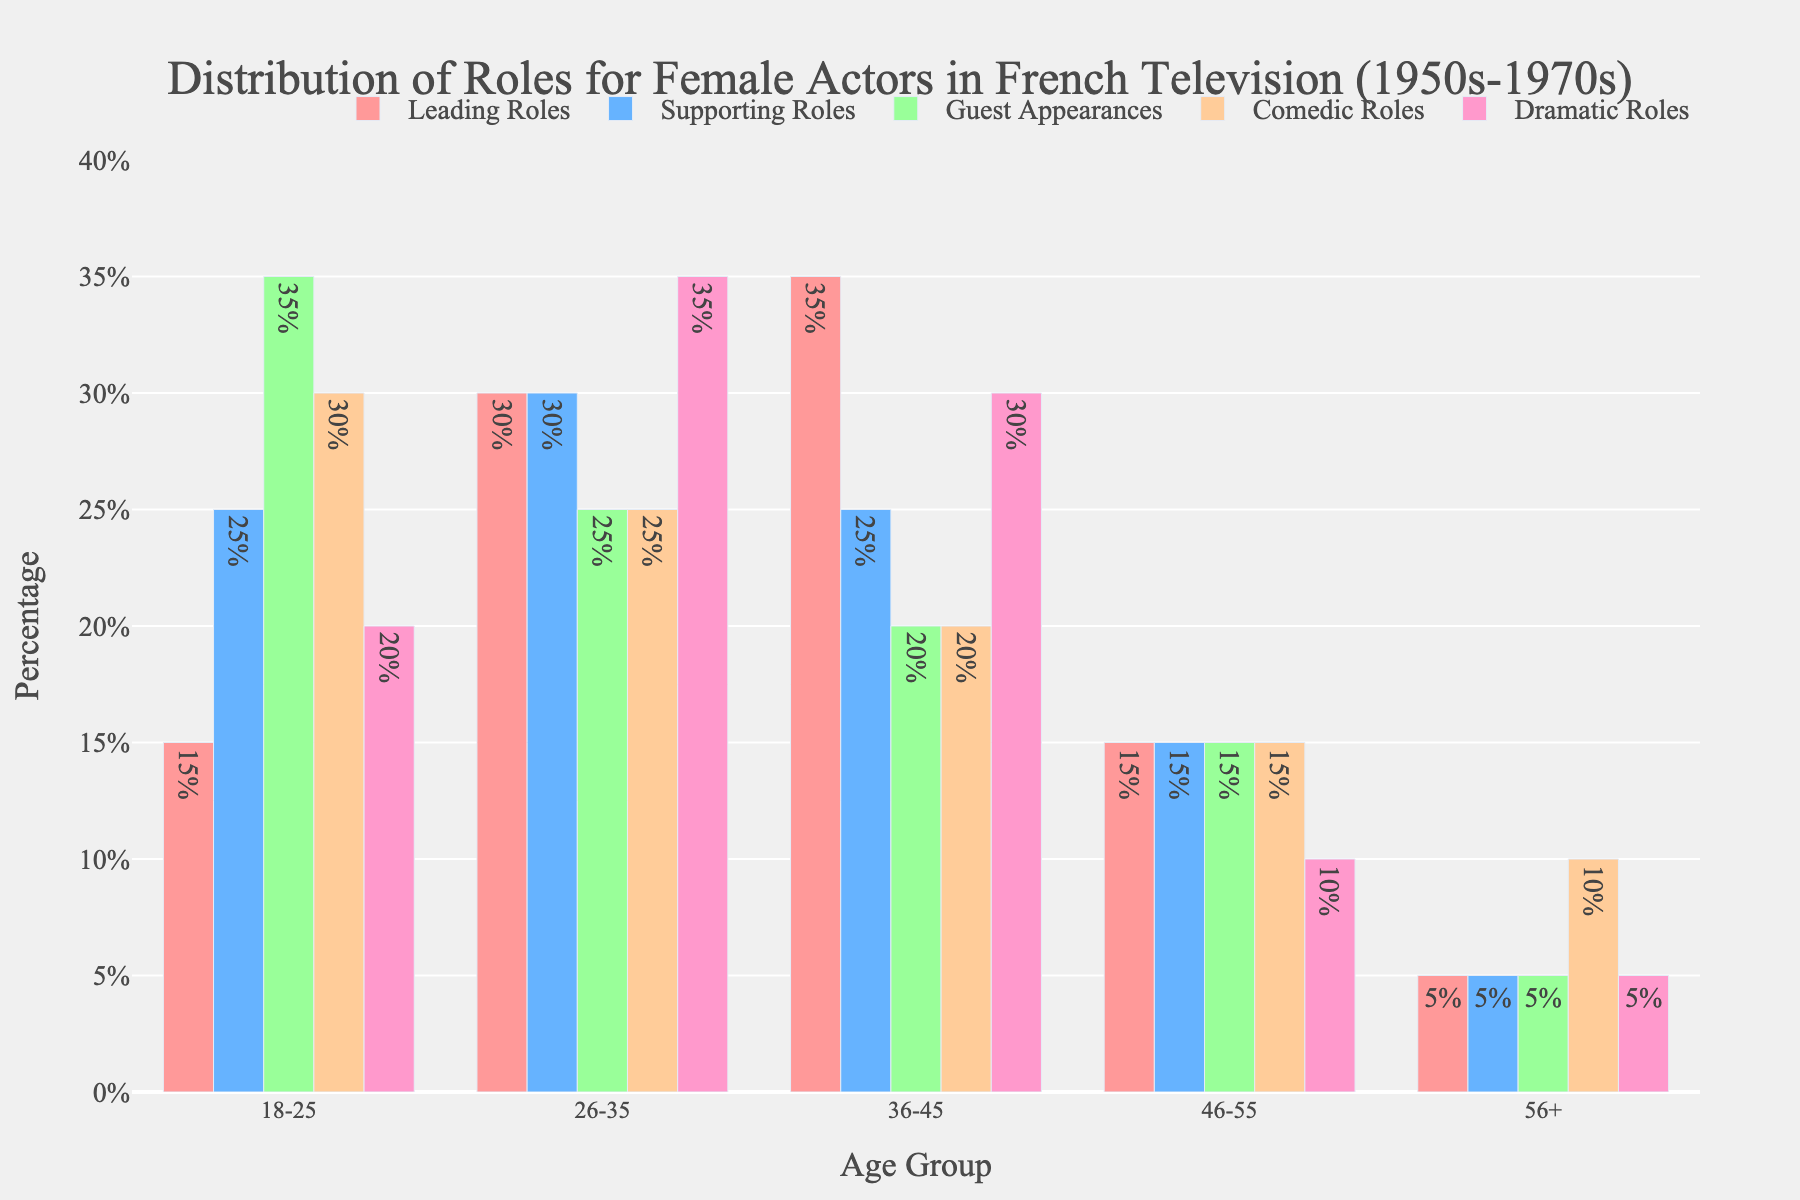Which age group has the highest percentage of leading roles? By looking at the bar representing "Leading Roles" across age groups, the tallest bar indicates the highest percentage. For Leading Roles, the tallest bar is in the age group "36-45".
Answer: 36-45 Among the age groups 26-35 and 46-55, which has a greater percentage of guest appearances? Compare the height (or length) of the bars for "Guest Appearances" in age groups 26-35 and 46-55. The bar for 26-35 is taller than 46-55.
Answer: 26-35 What is the total percentage of comedic roles for all age groups combined? Sum the percentages of "Comedic Roles" for all age groups: 30% + 25% + 20% + 15% + 10%. This equals 100%.
Answer: 100% Which role type has a higher percentage for the age group 18-25: dramatic roles or comedic roles? Compare the heights of the bars for "Dramatic Roles" and "Comedic Roles" within the 18-25 age group. The bar for Comedic Roles (30%) is higher than the bar for Dramatic Roles (20%).
Answer: Comedic Roles Which age group has the lowest percentage of supporting roles? By examining the bars for "Supporting Roles", the shortest bar indicates the lowest percentage. For Supporting Roles, the shortest bar is in the age group "56+".
Answer: 56+ What is the difference in percentage of leading roles between age groups 36-45 and 46-55? Subtract the percentage of Leading Roles in age group 46-55 from that in age group 36-45: 35% - 15%, giving a difference of 20%.
Answer: 20% How much higher is the percentage of supporting roles in the age group 26-35 compared to the age group 46-55? Subtract the percentage of Supporting Roles in age group 46-55 from that in age group 26-35: 30% - 15%, giving a difference of 15%.
Answer: 15% Which role type has relatively consistent percentages across all age groups? Observe the bar heights for each role type across all age groups. "Supporting Roles" has relatively similar bar heights (25%, 30%, 25%, 15%, 5%).
Answer: Supporting Roles In the age group 56+, what is the ratio of comedic roles to leading roles? Divide the percentage of Comedic Roles by the percentage of Leading Roles for age group 56+: 10% / 5%, resulting in a ratio of 2:1.
Answer: 2:1 Which age group has the most balanced distribution of role types? Check for an age group where bar heights for all role types are closest to each other. The age group "46-55" has similar percentages across all role types (15% for each, except Dramatic Roles at 10%).
Answer: 46-55 